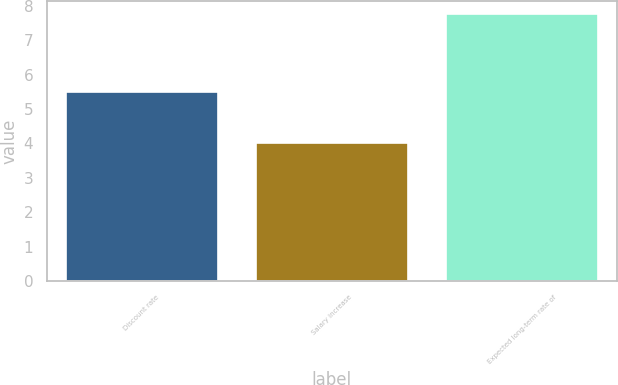Convert chart. <chart><loc_0><loc_0><loc_500><loc_500><bar_chart><fcel>Discount rate<fcel>Salary increase<fcel>Expected long-term rate of<nl><fcel>5.5<fcel>4<fcel>7.75<nl></chart> 